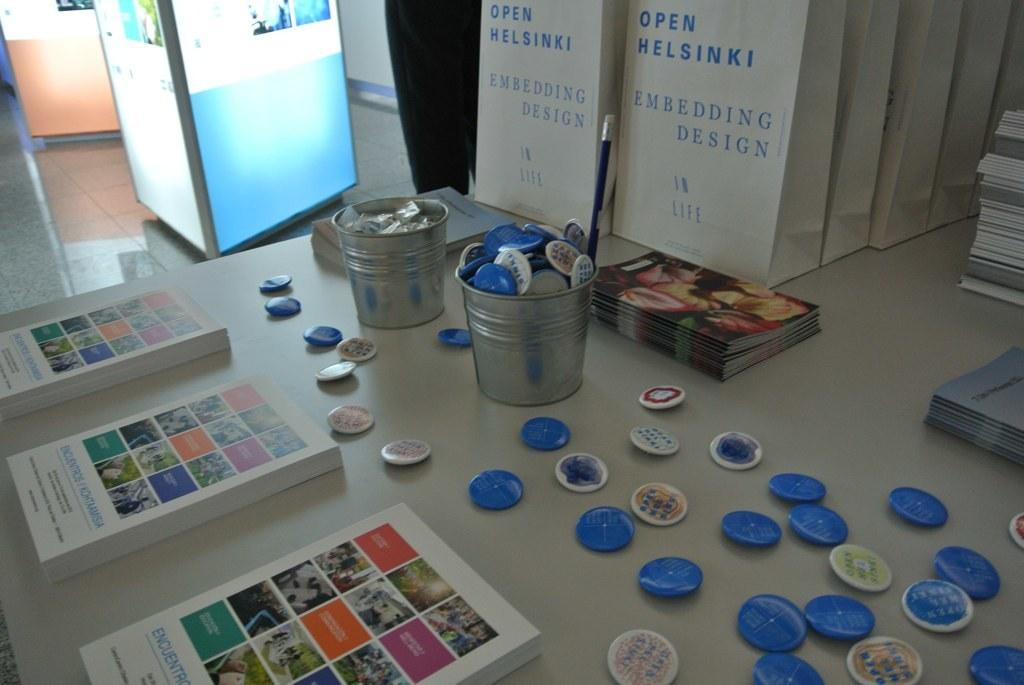<image>
Share a concise interpretation of the image provided. Buckets of buttons in front of an Open Helsinki book. 